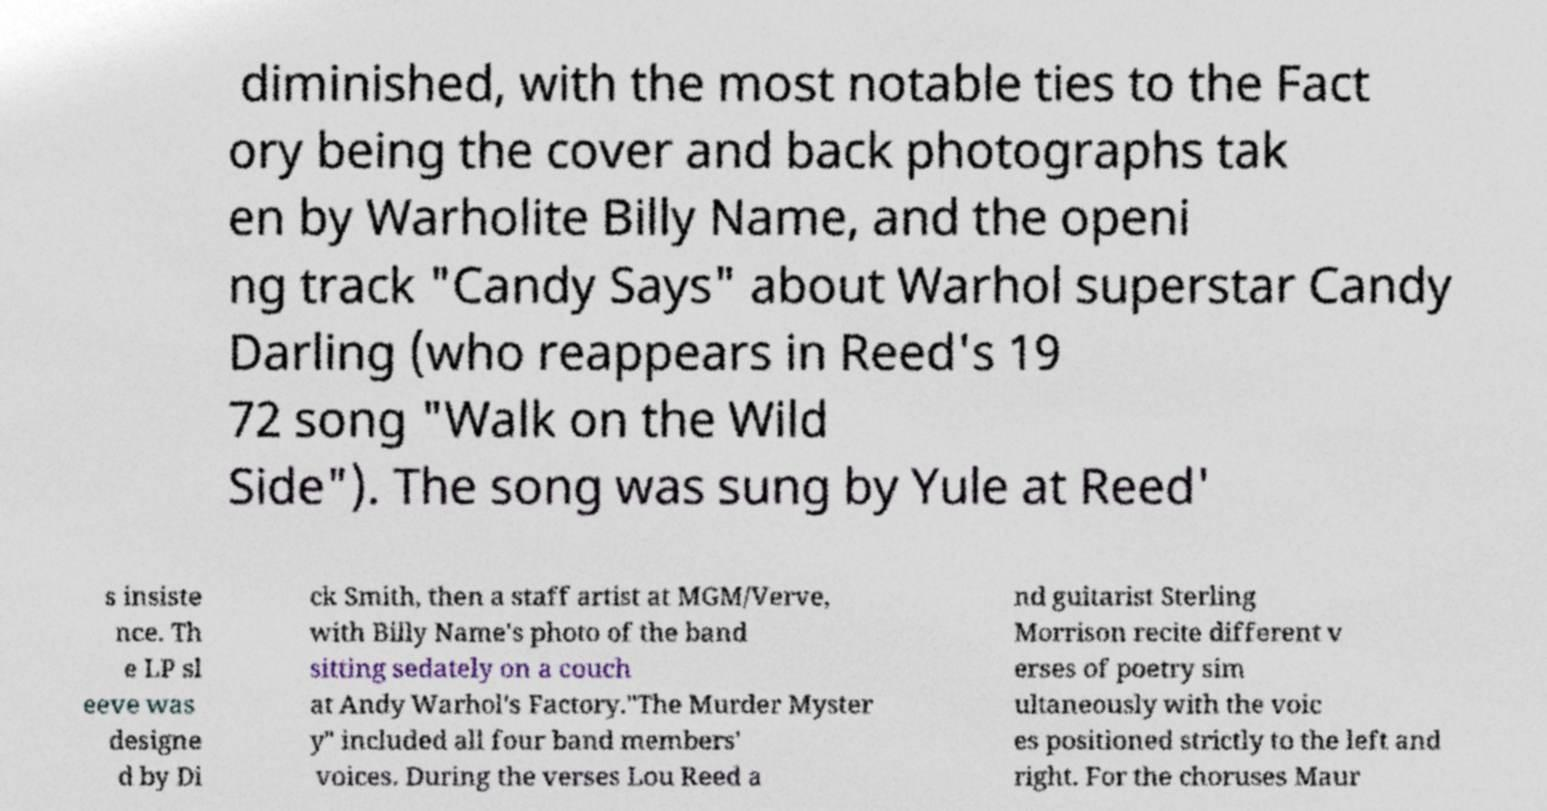What messages or text are displayed in this image? I need them in a readable, typed format. diminished, with the most notable ties to the Fact ory being the cover and back photographs tak en by Warholite Billy Name, and the openi ng track "Candy Says" about Warhol superstar Candy Darling (who reappears in Reed's 19 72 song "Walk on the Wild Side"). The song was sung by Yule at Reed' s insiste nce. Th e LP sl eeve was designe d by Di ck Smith, then a staff artist at MGM/Verve, with Billy Name's photo of the band sitting sedately on a couch at Andy Warhol's Factory."The Murder Myster y" included all four band members' voices. During the verses Lou Reed a nd guitarist Sterling Morrison recite different v erses of poetry sim ultaneously with the voic es positioned strictly to the left and right. For the choruses Maur 